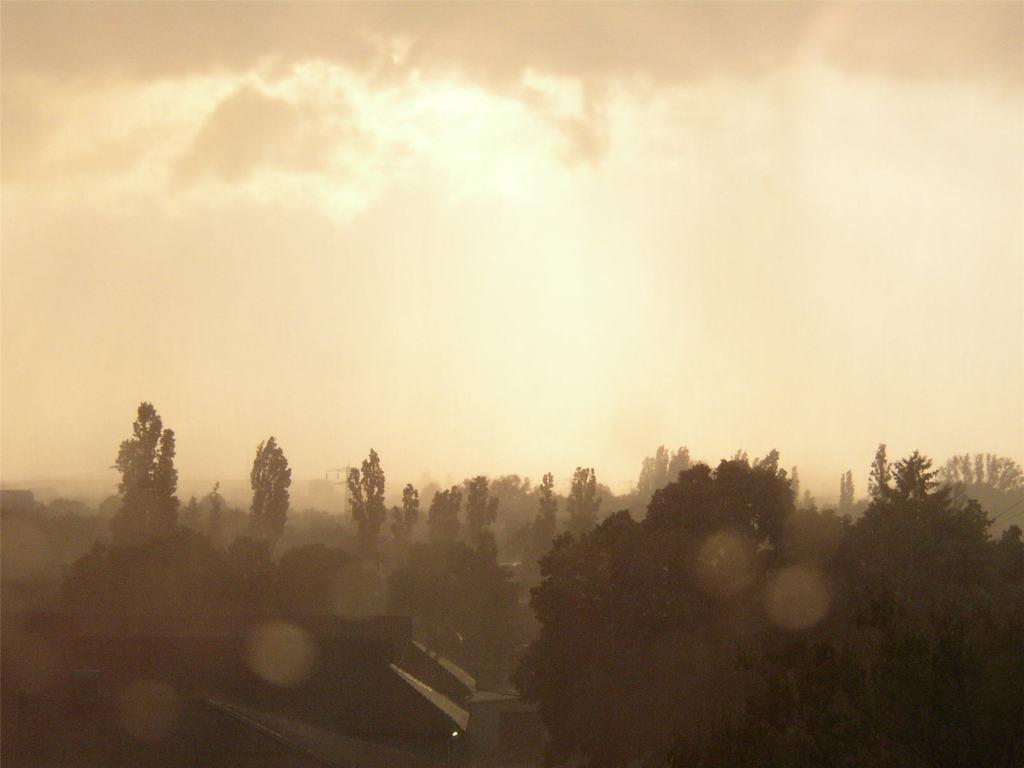Please provide a concise description of this image. In this image there is a building, trees,sky. 